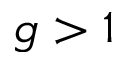Convert formula to latex. <formula><loc_0><loc_0><loc_500><loc_500>g > 1</formula> 